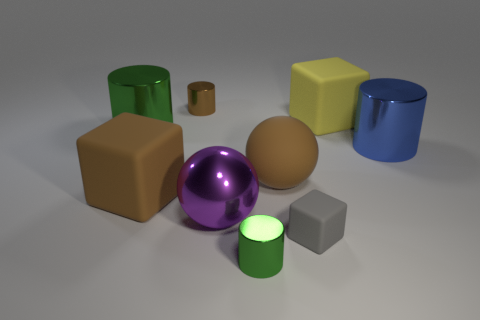Add 1 large brown rubber balls. How many objects exist? 10 Subtract all blue cylinders. How many cylinders are left? 3 Subtract all large cubes. How many cubes are left? 1 Subtract 0 cyan spheres. How many objects are left? 9 Subtract all blocks. How many objects are left? 6 Subtract 3 cylinders. How many cylinders are left? 1 Subtract all cyan spheres. Subtract all yellow blocks. How many spheres are left? 2 Subtract all purple cylinders. How many yellow blocks are left? 1 Subtract all big yellow rubber things. Subtract all purple shiny things. How many objects are left? 7 Add 1 big matte things. How many big matte things are left? 4 